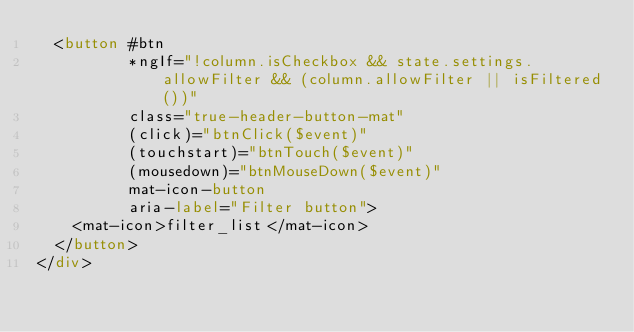Convert code to text. <code><loc_0><loc_0><loc_500><loc_500><_HTML_>  <button #btn
          *ngIf="!column.isCheckbox && state.settings.allowFilter && (column.allowFilter || isFiltered())"
          class="true-header-button-mat"
          (click)="btnClick($event)"
          (touchstart)="btnTouch($event)"
          (mousedown)="btnMouseDown($event)"
          mat-icon-button
          aria-label="Filter button">
    <mat-icon>filter_list</mat-icon>
  </button>
</div>
</code> 